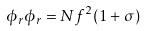Convert formula to latex. <formula><loc_0><loc_0><loc_500><loc_500>\phi _ { r } \phi _ { r } = N f ^ { 2 } ( 1 + \sigma )</formula> 